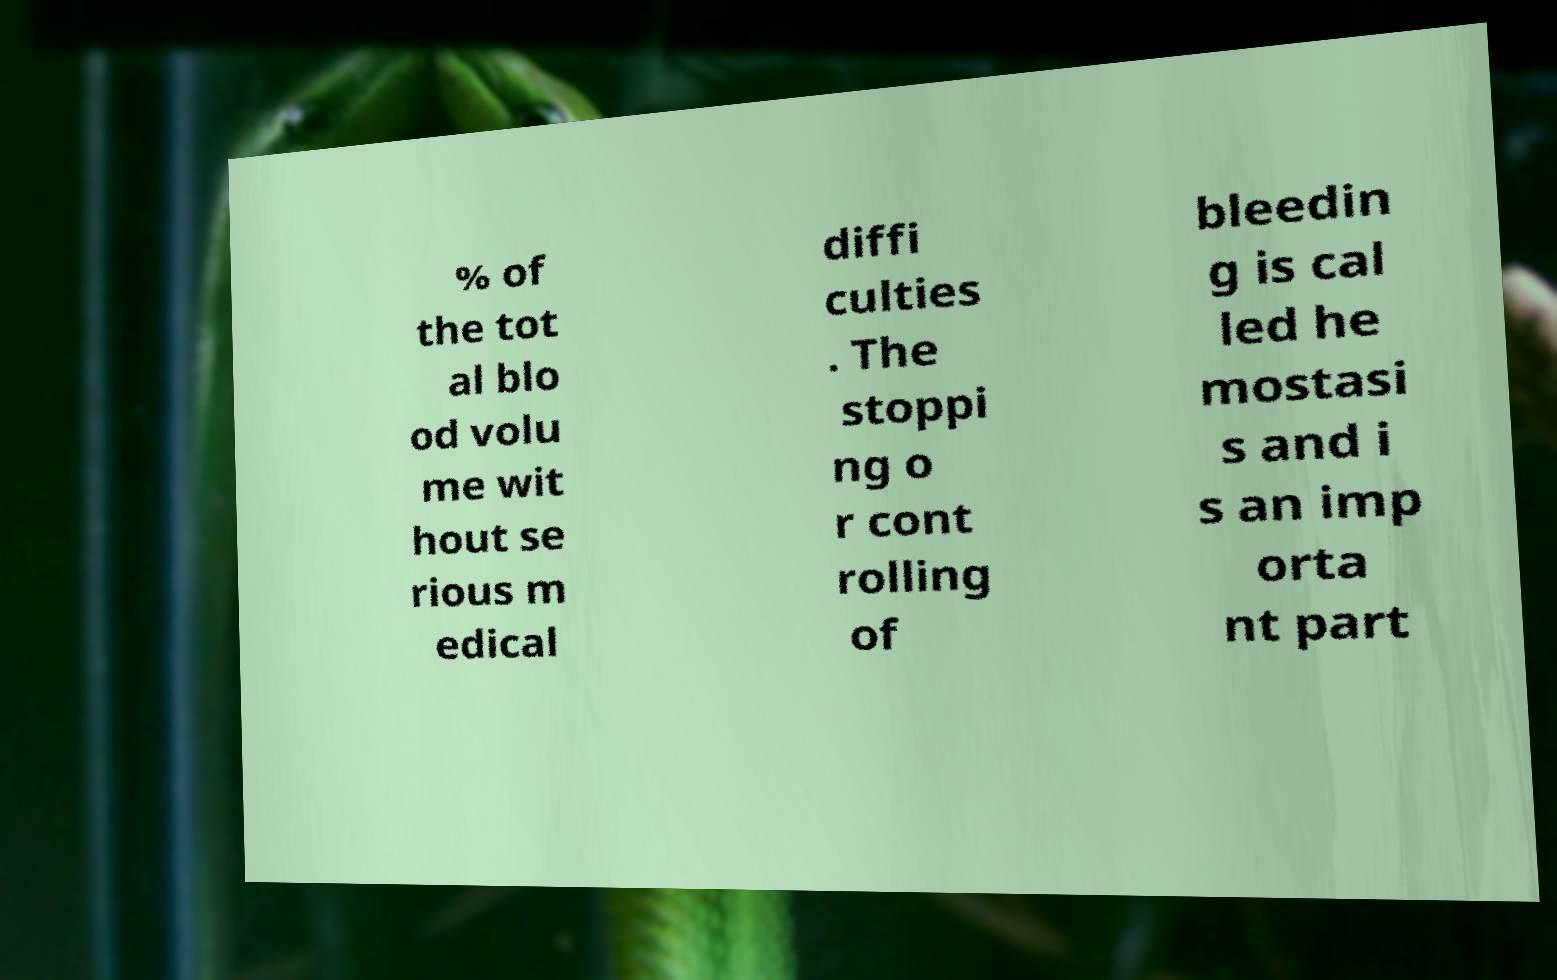I need the written content from this picture converted into text. Can you do that? % of the tot al blo od volu me wit hout se rious m edical diffi culties . The stoppi ng o r cont rolling of bleedin g is cal led he mostasi s and i s an imp orta nt part 